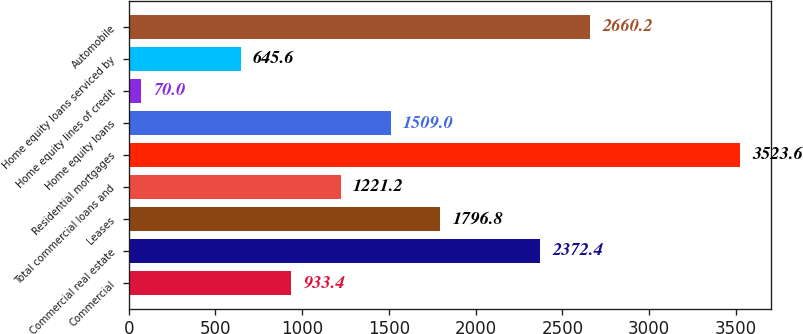Convert chart to OTSL. <chart><loc_0><loc_0><loc_500><loc_500><bar_chart><fcel>Commercial<fcel>Commercial real estate<fcel>Leases<fcel>Total commercial loans and<fcel>Residential mortgages<fcel>Home equity loans<fcel>Home equity lines of credit<fcel>Home equity loans serviced by<fcel>Automobile<nl><fcel>933.4<fcel>2372.4<fcel>1796.8<fcel>1221.2<fcel>3523.6<fcel>1509<fcel>70<fcel>645.6<fcel>2660.2<nl></chart> 